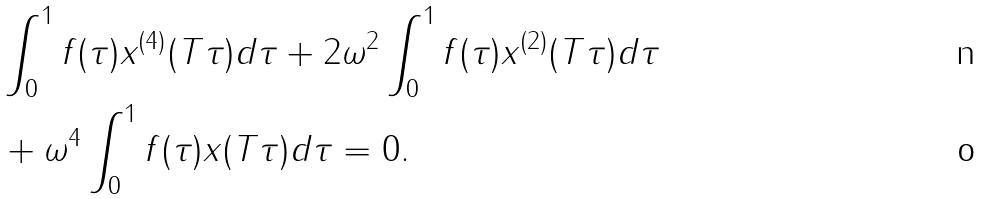Convert formula to latex. <formula><loc_0><loc_0><loc_500><loc_500>& \int _ { 0 } ^ { 1 } f ( \tau ) { x } ^ { ( 4 ) } ( T \tau ) d \tau + 2 \omega ^ { 2 } \int _ { 0 } ^ { 1 } f ( \tau ) x ^ { ( 2 ) } ( T \tau ) d \tau \\ & + \omega ^ { 4 } \int _ { 0 } ^ { 1 } f ( \tau ) x ( T \tau ) d \tau = 0 .</formula> 